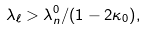<formula> <loc_0><loc_0><loc_500><loc_500>\lambda _ { \ell } > { \lambda _ { n } ^ { 0 } } / { ( 1 - 2 \kappa _ { 0 } ) } ,</formula> 